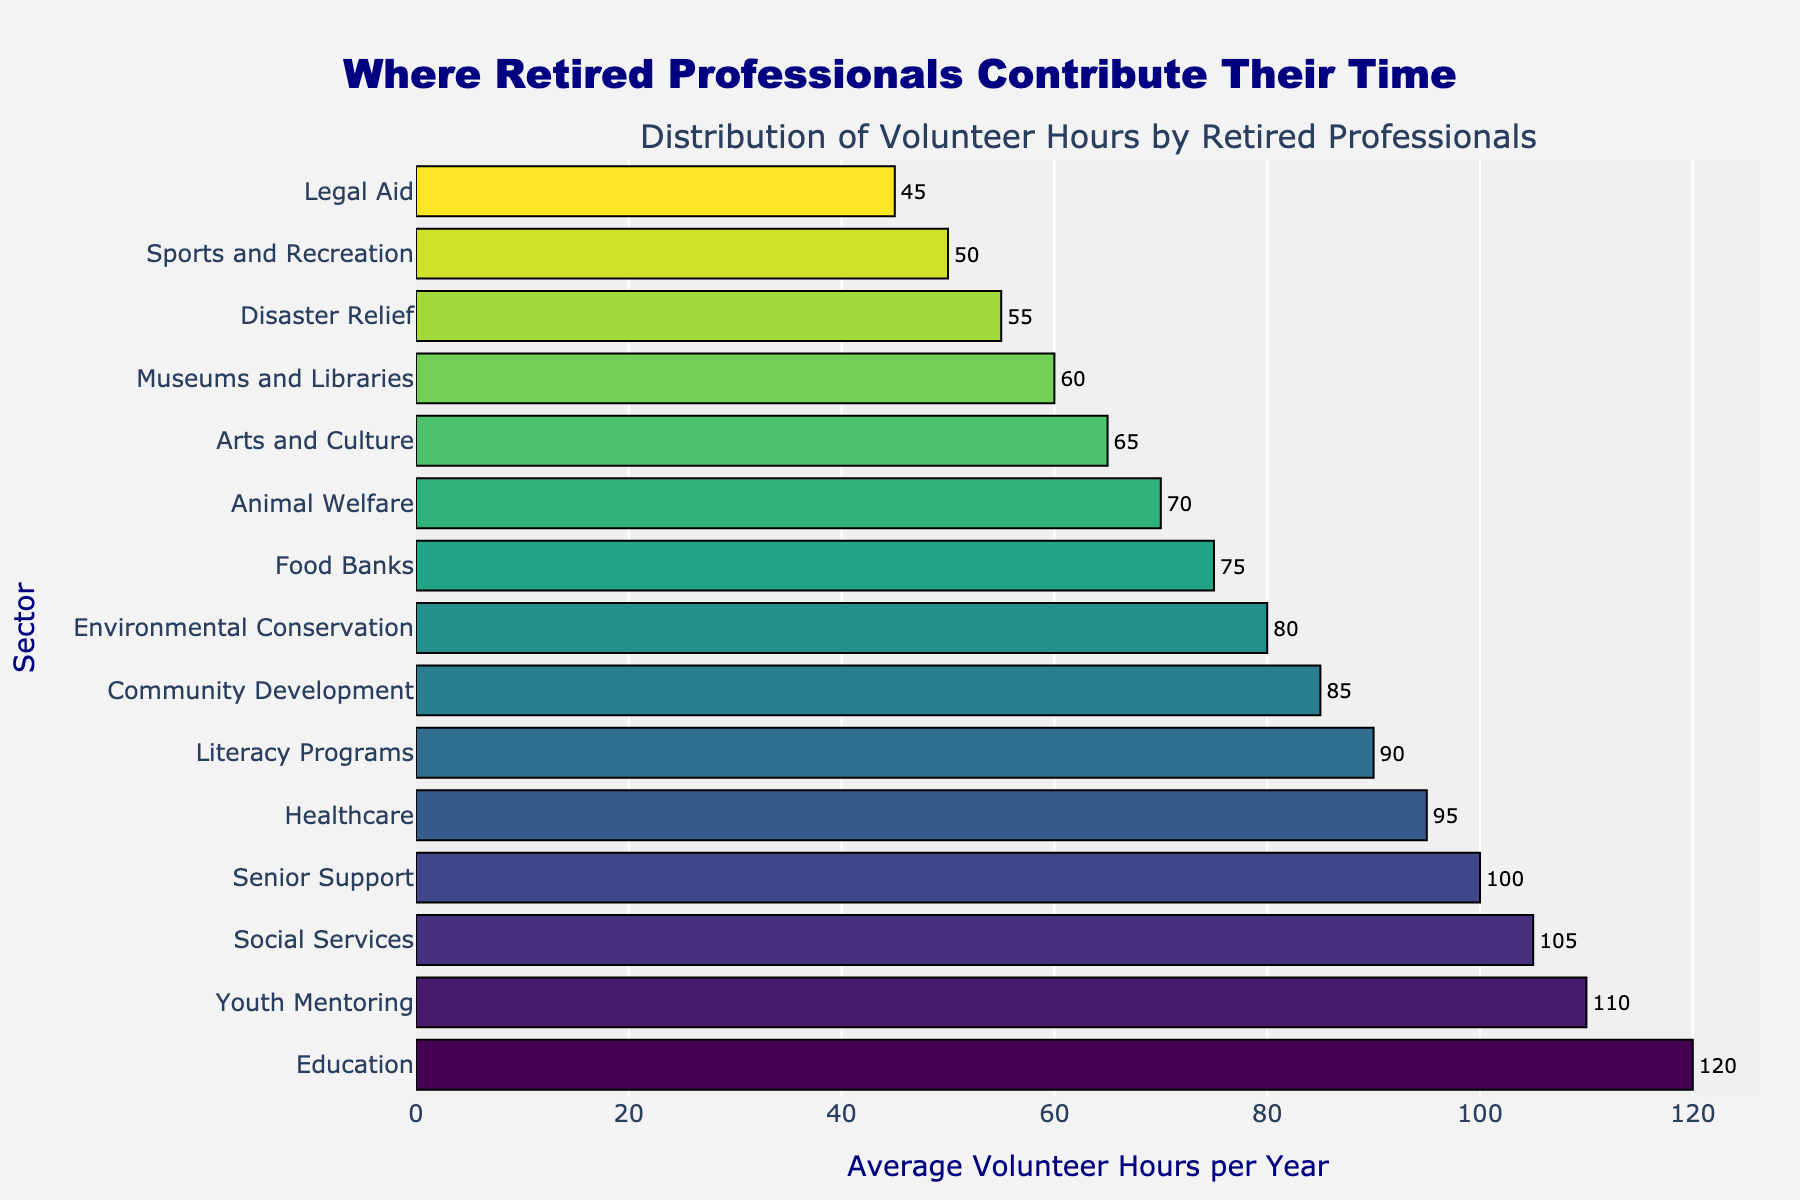Which sector has the highest average volunteer hours per year? To find out which sector has the highest average volunteer hours, we look at the longest bar in the chart. The education sector has the longest bar, indicating it has the highest average volunteer hours.
Answer: Education Which sector has the lowest average volunteer hours per year? To determine the sector with the lowest average volunteer hours, we look for the shortest bar in the chart. The legal aid sector has the shortest bar.
Answer: Legal Aid How many more hours on average do retired professionals spend volunteering in education compared to healthcare? From the chart, the education sector has 120 hours and healthcare has 95 hours. The difference is calculated as 120 - 95.
Answer: 25 Which sectors have average volunteer hours between 60 and 100 per year? The sectors with bar lengths falling between 60 and 100 are identified by reading their values. This includes senior support, literacy programs, social services, community development, and animal welfare.
Answer: Senior Support, Literacy Programs, Social Services, Community Development, Animal Welfare What is the combined average volunteer hours of the top three sectors? The top three sectors in terms of average volunteer hours are education (120), youth mentoring (110), and social services (105). Adding these together, the sum is 120 + 110 + 105.
Answer: 335 By how much do volunteer hours in the environmental conservation sector exceed those in sports and recreation? The environmental conservation sector has an average of 80 volunteer hours, whereas sports and recreation have 50. Subtracting these gives 80 - 50.
Answer: 30 Are there any sectors with exactly 75 average volunteer hours per year? Checking the bar lengths, we see the food banks sector has exactly 75 hours.
Answer: Food Banks Which sector shows the fourth smallest average volunteer hours per year? Listing the volunteer hours in ascending order, the fourth smallest is identified. The order starting from the smallest would go legal aid, sports and recreation, disaster relief, and then museums and libraries.
Answer: Museums and Libraries How many sectors have an average volunteer hours greater than 100? By examining the chart, sectors with more than 100 hours are education (120), youth mentoring (110), and social services (105). These total to three sectors.
Answer: 3 What is the average number of volunteer hours across all sectors? Summing all the average volunteer hours and dividing by the number of sectors (15) gives the average. The sum is 120 + 95 + 105 + 80 + 65 + 85 + 110 + 100 + 70 + 55 + 90 + 75 + 60 + 50 + 45 = 1205. So, 1205/15.
Answer: 80.33 